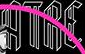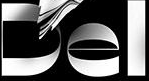What text is displayed in these images sequentially, separated by a semicolon? ATRE; Del 